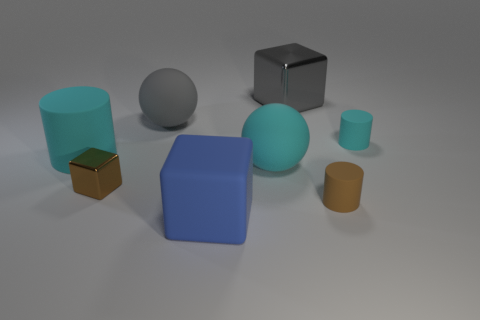Are these objects arranged in a specific pattern or order? The objects appear to be randomly placed with no discernible pattern. Their varied sizes and spacing do not suggest an intentional sequence or arrangement. 